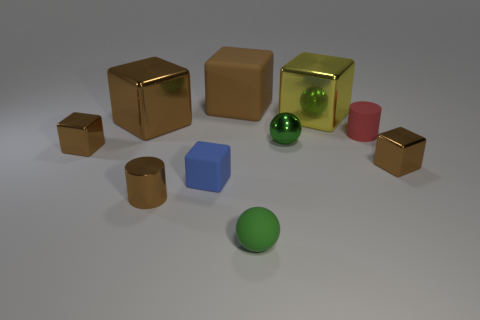Are any large yellow shiny objects visible?
Offer a terse response. Yes. Are there any large blue objects that have the same material as the large yellow cube?
Provide a succinct answer. No. Is the number of brown matte cubes behind the large brown matte thing greater than the number of yellow shiny objects that are in front of the yellow thing?
Ensure brevity in your answer.  No. Does the brown metallic cylinder have the same size as the metallic sphere?
Offer a terse response. Yes. What color is the matte thing behind the large metallic block that is left of the large rubber cube?
Ensure brevity in your answer.  Brown. The shiny cylinder is what color?
Provide a short and direct response. Brown. Are there any other things of the same color as the big rubber thing?
Offer a terse response. Yes. Is the color of the small shiny cube that is right of the tiny red rubber object the same as the tiny rubber cylinder?
Make the answer very short. No. What number of objects are either brown metallic things that are to the right of the blue rubber cube or small things?
Offer a very short reply. 7. There is a big yellow thing; are there any brown objects behind it?
Keep it short and to the point. Yes. 